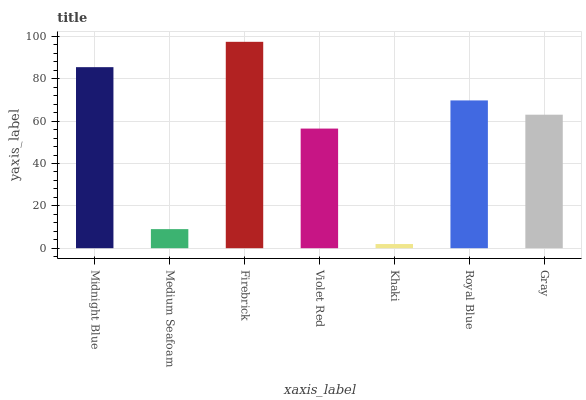Is Khaki the minimum?
Answer yes or no. Yes. Is Firebrick the maximum?
Answer yes or no. Yes. Is Medium Seafoam the minimum?
Answer yes or no. No. Is Medium Seafoam the maximum?
Answer yes or no. No. Is Midnight Blue greater than Medium Seafoam?
Answer yes or no. Yes. Is Medium Seafoam less than Midnight Blue?
Answer yes or no. Yes. Is Medium Seafoam greater than Midnight Blue?
Answer yes or no. No. Is Midnight Blue less than Medium Seafoam?
Answer yes or no. No. Is Gray the high median?
Answer yes or no. Yes. Is Gray the low median?
Answer yes or no. Yes. Is Royal Blue the high median?
Answer yes or no. No. Is Khaki the low median?
Answer yes or no. No. 